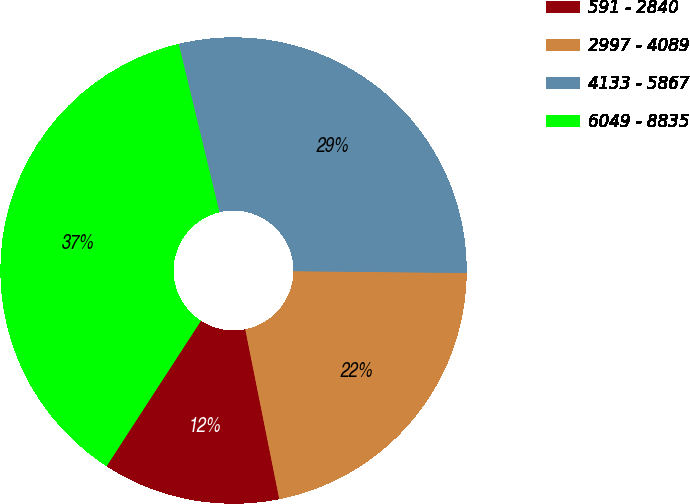Convert chart to OTSL. <chart><loc_0><loc_0><loc_500><loc_500><pie_chart><fcel>591 - 2840<fcel>2997 - 4089<fcel>4133 - 5867<fcel>6049 - 8835<nl><fcel>12.31%<fcel>21.69%<fcel>28.95%<fcel>37.06%<nl></chart> 